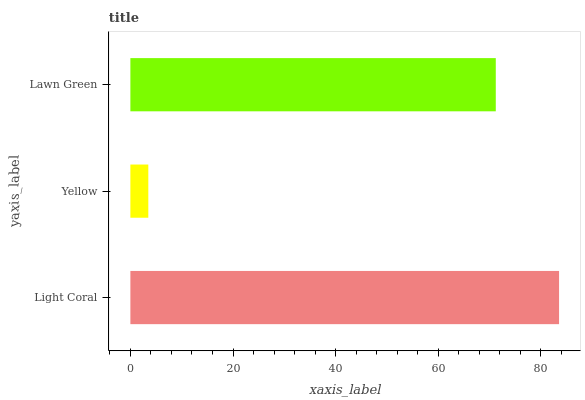Is Yellow the minimum?
Answer yes or no. Yes. Is Light Coral the maximum?
Answer yes or no. Yes. Is Lawn Green the minimum?
Answer yes or no. No. Is Lawn Green the maximum?
Answer yes or no. No. Is Lawn Green greater than Yellow?
Answer yes or no. Yes. Is Yellow less than Lawn Green?
Answer yes or no. Yes. Is Yellow greater than Lawn Green?
Answer yes or no. No. Is Lawn Green less than Yellow?
Answer yes or no. No. Is Lawn Green the high median?
Answer yes or no. Yes. Is Lawn Green the low median?
Answer yes or no. Yes. Is Yellow the high median?
Answer yes or no. No. Is Yellow the low median?
Answer yes or no. No. 